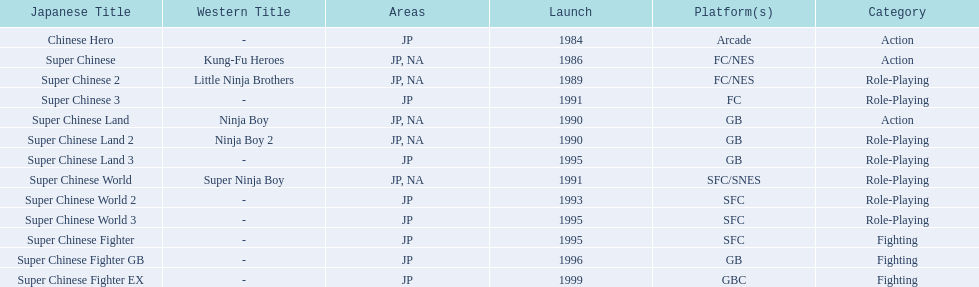What are the total of super chinese games released? 13. 